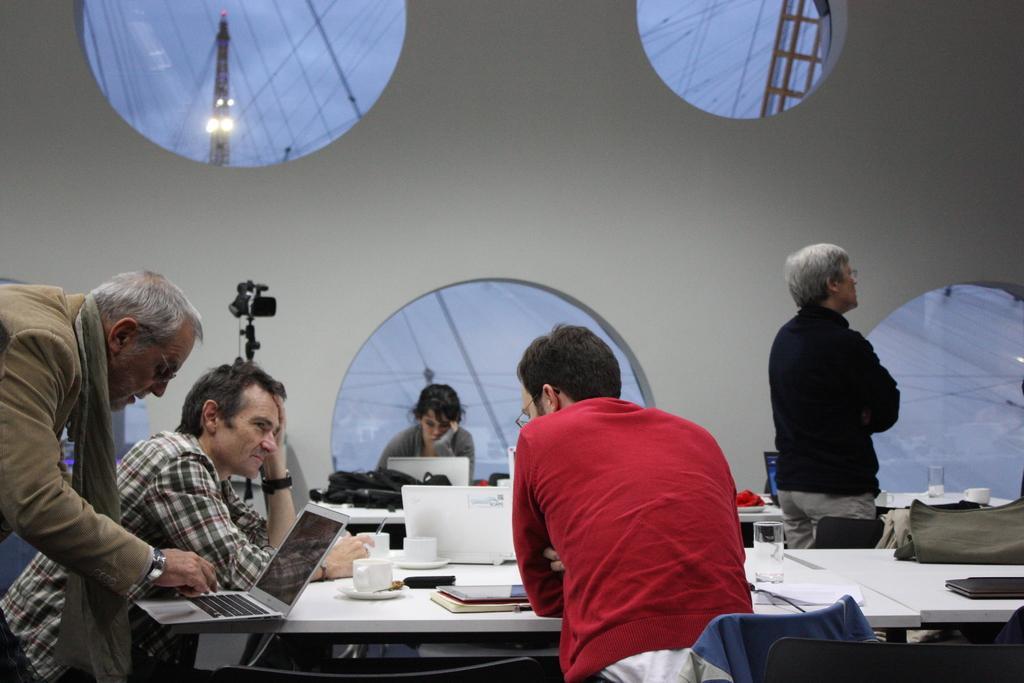Describe this image in one or two sentences. There is a room. There is a group of people. They are standing. In the center we have a woman. She is sitting on a chair. There is a table. There is a laptop,book,glass ,bag on a table. We can see in background white wall and camera. 